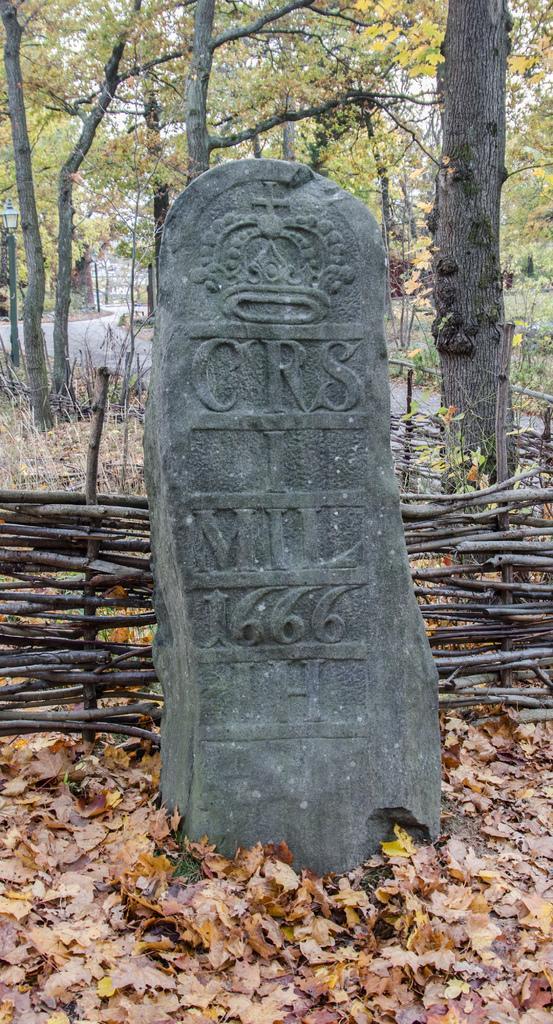Please provide a concise description of this image. In this image we can see a laid stone, shredded leaves on the ground, wooden fence, trees, roads and sky. 